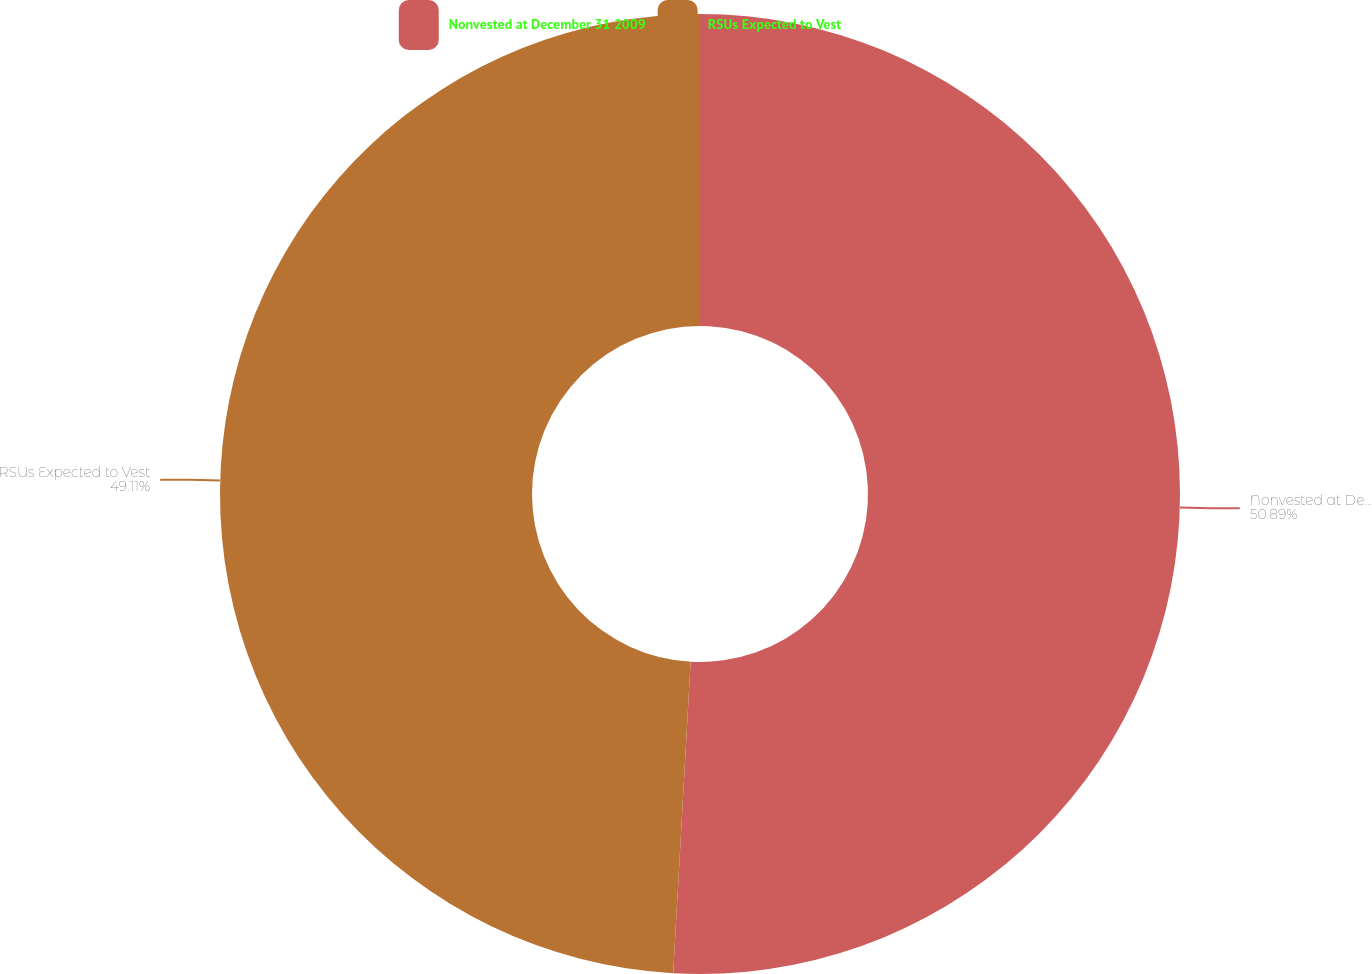<chart> <loc_0><loc_0><loc_500><loc_500><pie_chart><fcel>Nonvested at December 31 2009<fcel>RSUs Expected to Vest<nl><fcel>50.89%<fcel>49.11%<nl></chart> 